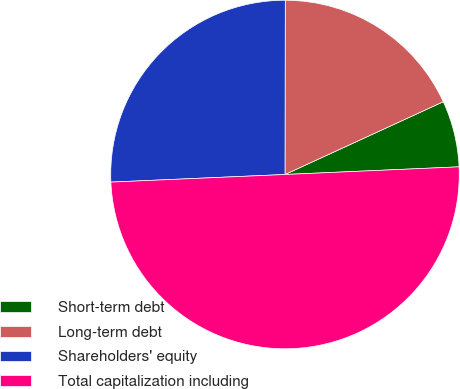<chart> <loc_0><loc_0><loc_500><loc_500><pie_chart><fcel>Short-term debt<fcel>Long-term debt<fcel>Shareholders' equity<fcel>Total capitalization including<nl><fcel>6.16%<fcel>18.11%<fcel>25.72%<fcel>50.0%<nl></chart> 